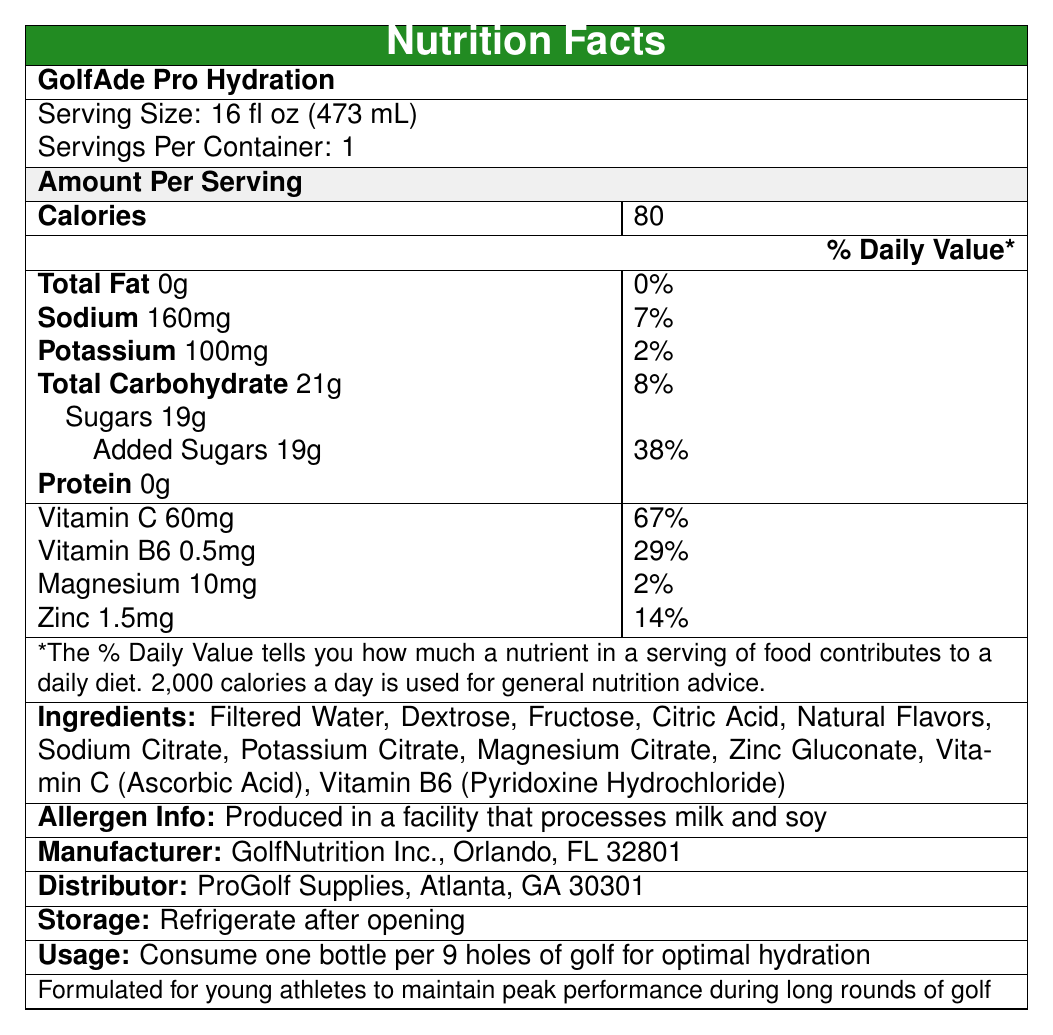what is the serving size for GolfAde Pro Hydration? The serving size is clearly stated under the product name as 16 fl oz (473 mL).
Answer: 16 fl oz (473 mL) how many calories are in one serving of GolfAde Pro Hydration? The calories per serving are listed as 80 in the document.
Answer: 80 what is the amount of sodium per serving? The document states that the amount of sodium per serving is 160mg.
Answer: 160mg what is the daily value percentage for added sugars? The daily value percentage for added sugars is shown as 38% in the document.
Answer: 38% what vitamins are included in GolfAde Pro Hydration? The ingredients list includes Vitamin C (Ascorbic Acid) and Vitamin B6 (Pyridoxine Hydrochloride).
Answer: Vitamin C and Vitamin B6 how many grams of protein are in a serving of GolfAde Pro Hydration? The amount of protein listed is 0g per serving.
Answer: 0g which ingredient is listed first in the ingredients list? A. Sodium Citrate B. Fructose C. Filtered Water D. Vitamin C Filtered Water is the first ingredient listed, indicating it's the primary component.
Answer: C how many servings are there per container of GolfAde Pro Hydration? A. 1 B. 2 C. 3 D. 4 The document specifies that there is 1 serving per container.
Answer: A is GolfAde Pro Hydration suitable for people with milk allergies? The allergen information notes that it is produced in a facility that processes milk and soy.
Answer: No describe the main idea of the document. The document is focused on detailing the nutritional content and other important details such as allergen information, ingredients, and usage instructions for the sports drink.
Answer: The main idea of the document is to provide detailed nutrition information for GolfAde Pro Hydration, a sports drink designed to enhance hydration for young athletes during golf rounds. It includes the serving size, calorie content, nutrient amounts, ingredients, allergen information, storage, and usage instructions. what company manufactures GolfAde Pro Hydration? The manufacturer is listed as GolfNutrition Inc., located in Orlando, FL.
Answer: GolfNutrition Inc. how should GolfAde Pro Hydration be stored after opening? The storage instruction clearly states to refrigerate after opening.
Answer: Refrigerate after opening how many milligrams of magnesium are in a serving? The document shows that each serving contains 10mg of magnesium.
Answer: 10mg is there any information about the protein source in the drink? The document states the drink contains 0g of protein and does not provide any details about a protein source.
Answer: Cannot be determined how many grams of total carbohydrates are there in a serving? A. 21g B. 19g C. 15g D. 10g The document states that each serving contains 21g of total carbohydrates.
Answer: A are there any added sugars in GolfAde Pro Hydration? A. Yes B. No The document specifies that there are 19g of added sugars in each serving.
Answer: A where should you consume one bottle of GolfAde Pro Hydration for optimal hydration? The usage instructions recommend consuming one bottle per 9 holes of golf for optimal hydration.
Answer: Per 9 holes of golf what is the daily value percentage for vitamin B6 in a serving? The document states that the daily value percentage for Vitamin B6 is 29%.
Answer: 29% what is the amount of potassium per serving? Each serving contains 100mg of potassium, as indicated in the document.
Answer: 100mg what is the total calorie diet used for general nutrition advice according to the document? The footnote mentions that a 2,000 calorie diet is used for general nutrition advice.
Answer: 2,000 calories a day 